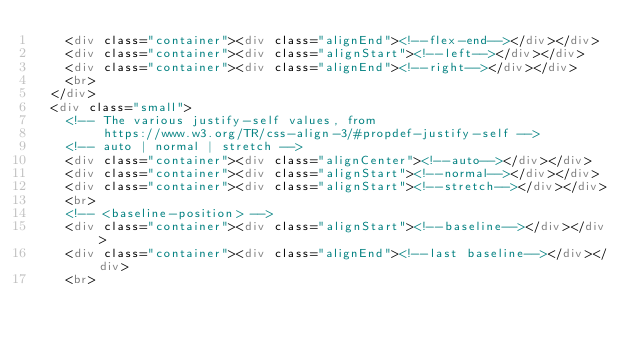Convert code to text. <code><loc_0><loc_0><loc_500><loc_500><_HTML_>    <div class="container"><div class="alignEnd"><!--flex-end--></div></div>
    <div class="container"><div class="alignStart"><!--left--></div></div>
    <div class="container"><div class="alignEnd"><!--right--></div></div>
    <br>
  </div>
  <div class="small">
    <!-- The various justify-self values, from
         https://www.w3.org/TR/css-align-3/#propdef-justify-self -->
    <!-- auto | normal | stretch -->
    <div class="container"><div class="alignCenter"><!--auto--></div></div>
    <div class="container"><div class="alignStart"><!--normal--></div></div>
    <div class="container"><div class="alignStart"><!--stretch--></div></div>
    <br>
    <!-- <baseline-position> -->
    <div class="container"><div class="alignStart"><!--baseline--></div></div>
    <div class="container"><div class="alignEnd"><!--last baseline--></div></div>
    <br></code> 